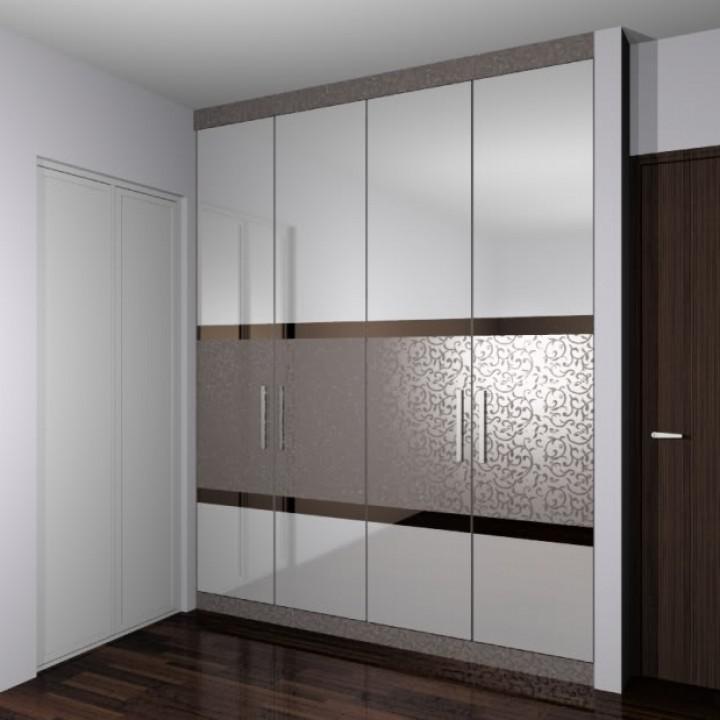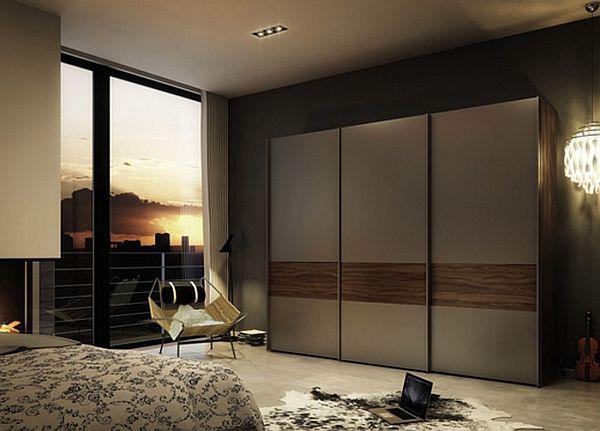The first image is the image on the left, the second image is the image on the right. For the images displayed, is the sentence "There are clothes visible in one of the closets." factually correct? Answer yes or no. No. The first image is the image on the left, the second image is the image on the right. Evaluate the accuracy of this statement regarding the images: "An image shows a wardrobe with pale beige panels and the sliding door partly open.". Is it true? Answer yes or no. No. 